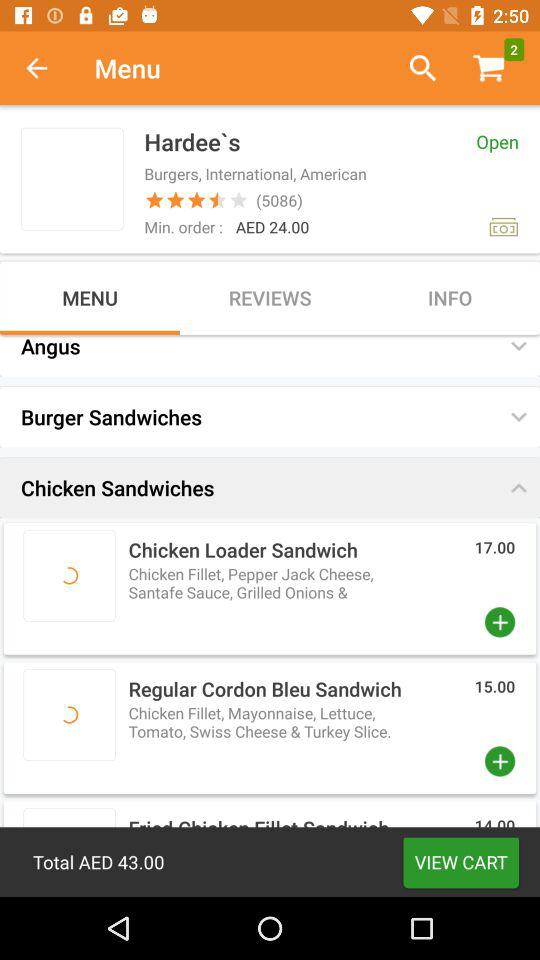What is the price of a regular cordon bleu sandwich? The price is 15.00. 